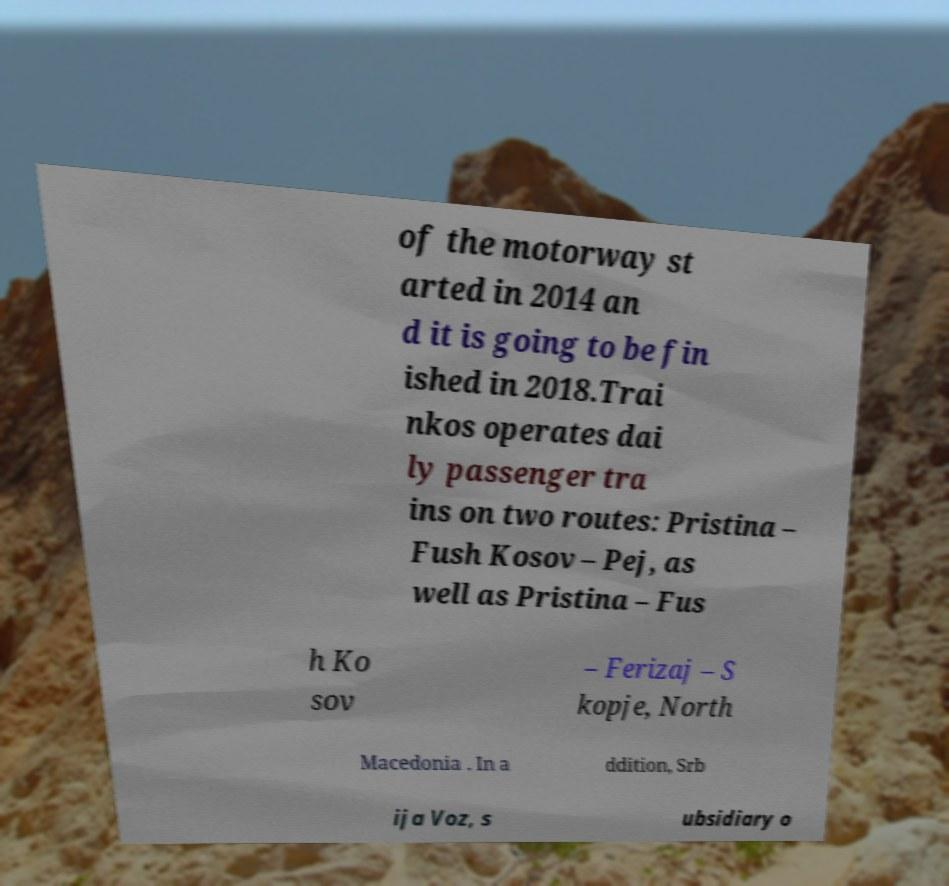Can you read and provide the text displayed in the image?This photo seems to have some interesting text. Can you extract and type it out for me? of the motorway st arted in 2014 an d it is going to be fin ished in 2018.Trai nkos operates dai ly passenger tra ins on two routes: Pristina – Fush Kosov – Pej, as well as Pristina – Fus h Ko sov – Ferizaj – S kopje, North Macedonia . In a ddition, Srb ija Voz, s ubsidiary o 